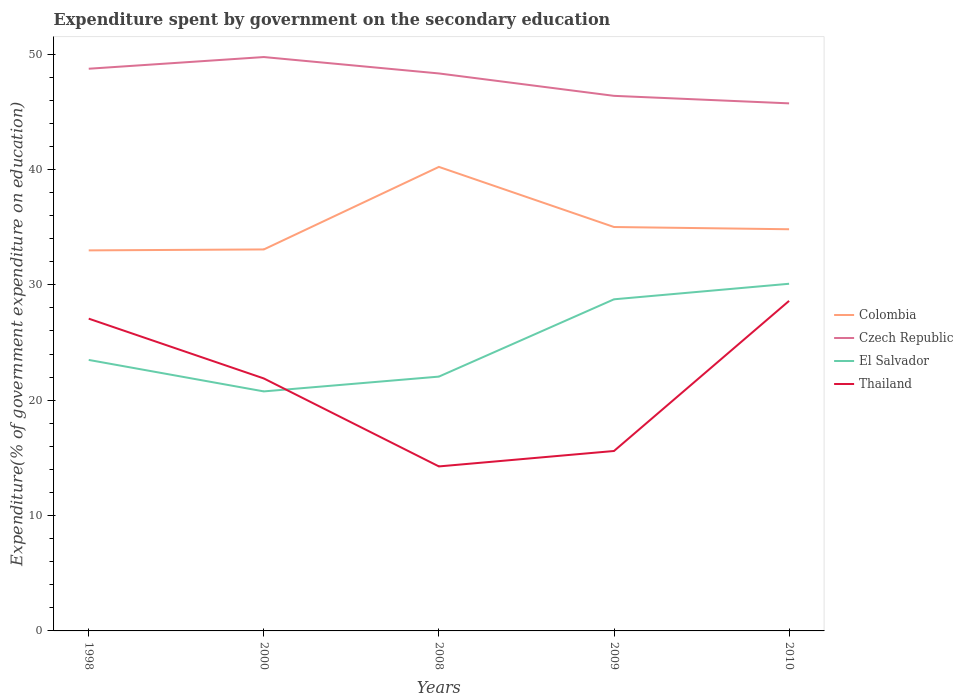How many different coloured lines are there?
Your response must be concise. 4. Does the line corresponding to El Salvador intersect with the line corresponding to Colombia?
Ensure brevity in your answer.  No. Across all years, what is the maximum expenditure spent by government on the secondary education in Thailand?
Keep it short and to the point. 14.26. What is the total expenditure spent by government on the secondary education in El Salvador in the graph?
Your answer should be very brief. -1.35. What is the difference between the highest and the second highest expenditure spent by government on the secondary education in Czech Republic?
Give a very brief answer. 4.02. What is the difference between the highest and the lowest expenditure spent by government on the secondary education in El Salvador?
Your response must be concise. 2. Is the expenditure spent by government on the secondary education in Thailand strictly greater than the expenditure spent by government on the secondary education in El Salvador over the years?
Offer a terse response. No. How many lines are there?
Your answer should be very brief. 4. What is the difference between two consecutive major ticks on the Y-axis?
Keep it short and to the point. 10. Are the values on the major ticks of Y-axis written in scientific E-notation?
Your response must be concise. No. Does the graph contain any zero values?
Offer a very short reply. No. Does the graph contain grids?
Provide a short and direct response. No. Where does the legend appear in the graph?
Your answer should be compact. Center right. How many legend labels are there?
Give a very brief answer. 4. How are the legend labels stacked?
Your response must be concise. Vertical. What is the title of the graph?
Ensure brevity in your answer.  Expenditure spent by government on the secondary education. What is the label or title of the Y-axis?
Your answer should be compact. Expenditure(% of government expenditure on education). What is the Expenditure(% of government expenditure on education) in Colombia in 1998?
Offer a terse response. 32.99. What is the Expenditure(% of government expenditure on education) of Czech Republic in 1998?
Your response must be concise. 48.74. What is the Expenditure(% of government expenditure on education) of El Salvador in 1998?
Provide a short and direct response. 23.49. What is the Expenditure(% of government expenditure on education) in Thailand in 1998?
Provide a succinct answer. 27.07. What is the Expenditure(% of government expenditure on education) of Colombia in 2000?
Offer a terse response. 33.07. What is the Expenditure(% of government expenditure on education) of Czech Republic in 2000?
Provide a short and direct response. 49.75. What is the Expenditure(% of government expenditure on education) of El Salvador in 2000?
Your answer should be very brief. 20.76. What is the Expenditure(% of government expenditure on education) in Thailand in 2000?
Provide a short and direct response. 21.89. What is the Expenditure(% of government expenditure on education) of Colombia in 2008?
Your response must be concise. 40.23. What is the Expenditure(% of government expenditure on education) in Czech Republic in 2008?
Give a very brief answer. 48.33. What is the Expenditure(% of government expenditure on education) in El Salvador in 2008?
Your answer should be compact. 22.05. What is the Expenditure(% of government expenditure on education) of Thailand in 2008?
Keep it short and to the point. 14.26. What is the Expenditure(% of government expenditure on education) in Colombia in 2009?
Provide a short and direct response. 35.01. What is the Expenditure(% of government expenditure on education) of Czech Republic in 2009?
Make the answer very short. 46.39. What is the Expenditure(% of government expenditure on education) in El Salvador in 2009?
Make the answer very short. 28.75. What is the Expenditure(% of government expenditure on education) of Thailand in 2009?
Your answer should be very brief. 15.6. What is the Expenditure(% of government expenditure on education) of Colombia in 2010?
Your answer should be very brief. 34.82. What is the Expenditure(% of government expenditure on education) of Czech Republic in 2010?
Offer a very short reply. 45.73. What is the Expenditure(% of government expenditure on education) in El Salvador in 2010?
Provide a succinct answer. 30.09. What is the Expenditure(% of government expenditure on education) in Thailand in 2010?
Your answer should be very brief. 28.61. Across all years, what is the maximum Expenditure(% of government expenditure on education) in Colombia?
Your answer should be compact. 40.23. Across all years, what is the maximum Expenditure(% of government expenditure on education) in Czech Republic?
Ensure brevity in your answer.  49.75. Across all years, what is the maximum Expenditure(% of government expenditure on education) of El Salvador?
Keep it short and to the point. 30.09. Across all years, what is the maximum Expenditure(% of government expenditure on education) in Thailand?
Your answer should be compact. 28.61. Across all years, what is the minimum Expenditure(% of government expenditure on education) in Colombia?
Your answer should be very brief. 32.99. Across all years, what is the minimum Expenditure(% of government expenditure on education) in Czech Republic?
Your response must be concise. 45.73. Across all years, what is the minimum Expenditure(% of government expenditure on education) of El Salvador?
Keep it short and to the point. 20.76. Across all years, what is the minimum Expenditure(% of government expenditure on education) in Thailand?
Provide a succinct answer. 14.26. What is the total Expenditure(% of government expenditure on education) in Colombia in the graph?
Give a very brief answer. 176.12. What is the total Expenditure(% of government expenditure on education) in Czech Republic in the graph?
Provide a succinct answer. 238.93. What is the total Expenditure(% of government expenditure on education) of El Salvador in the graph?
Give a very brief answer. 125.15. What is the total Expenditure(% of government expenditure on education) of Thailand in the graph?
Keep it short and to the point. 107.43. What is the difference between the Expenditure(% of government expenditure on education) in Colombia in 1998 and that in 2000?
Ensure brevity in your answer.  -0.08. What is the difference between the Expenditure(% of government expenditure on education) of Czech Republic in 1998 and that in 2000?
Make the answer very short. -1.01. What is the difference between the Expenditure(% of government expenditure on education) in El Salvador in 1998 and that in 2000?
Keep it short and to the point. 2.73. What is the difference between the Expenditure(% of government expenditure on education) in Thailand in 1998 and that in 2000?
Your answer should be very brief. 5.18. What is the difference between the Expenditure(% of government expenditure on education) of Colombia in 1998 and that in 2008?
Offer a terse response. -7.24. What is the difference between the Expenditure(% of government expenditure on education) of Czech Republic in 1998 and that in 2008?
Offer a very short reply. 0.41. What is the difference between the Expenditure(% of government expenditure on education) of El Salvador in 1998 and that in 2008?
Keep it short and to the point. 1.45. What is the difference between the Expenditure(% of government expenditure on education) in Thailand in 1998 and that in 2008?
Offer a very short reply. 12.81. What is the difference between the Expenditure(% of government expenditure on education) of Colombia in 1998 and that in 2009?
Give a very brief answer. -2.02. What is the difference between the Expenditure(% of government expenditure on education) in Czech Republic in 1998 and that in 2009?
Offer a very short reply. 2.35. What is the difference between the Expenditure(% of government expenditure on education) in El Salvador in 1998 and that in 2009?
Your response must be concise. -5.25. What is the difference between the Expenditure(% of government expenditure on education) in Thailand in 1998 and that in 2009?
Offer a terse response. 11.47. What is the difference between the Expenditure(% of government expenditure on education) of Colombia in 1998 and that in 2010?
Offer a very short reply. -1.83. What is the difference between the Expenditure(% of government expenditure on education) in Czech Republic in 1998 and that in 2010?
Give a very brief answer. 3. What is the difference between the Expenditure(% of government expenditure on education) in El Salvador in 1998 and that in 2010?
Offer a terse response. -6.6. What is the difference between the Expenditure(% of government expenditure on education) in Thailand in 1998 and that in 2010?
Your answer should be very brief. -1.54. What is the difference between the Expenditure(% of government expenditure on education) of Colombia in 2000 and that in 2008?
Keep it short and to the point. -7.16. What is the difference between the Expenditure(% of government expenditure on education) of Czech Republic in 2000 and that in 2008?
Your answer should be compact. 1.42. What is the difference between the Expenditure(% of government expenditure on education) of El Salvador in 2000 and that in 2008?
Provide a succinct answer. -1.28. What is the difference between the Expenditure(% of government expenditure on education) in Thailand in 2000 and that in 2008?
Provide a succinct answer. 7.63. What is the difference between the Expenditure(% of government expenditure on education) in Colombia in 2000 and that in 2009?
Offer a very short reply. -1.94. What is the difference between the Expenditure(% of government expenditure on education) in Czech Republic in 2000 and that in 2009?
Your response must be concise. 3.36. What is the difference between the Expenditure(% of government expenditure on education) of El Salvador in 2000 and that in 2009?
Your response must be concise. -7.98. What is the difference between the Expenditure(% of government expenditure on education) of Thailand in 2000 and that in 2009?
Your response must be concise. 6.29. What is the difference between the Expenditure(% of government expenditure on education) of Colombia in 2000 and that in 2010?
Your response must be concise. -1.75. What is the difference between the Expenditure(% of government expenditure on education) of Czech Republic in 2000 and that in 2010?
Offer a very short reply. 4.02. What is the difference between the Expenditure(% of government expenditure on education) in El Salvador in 2000 and that in 2010?
Your response must be concise. -9.33. What is the difference between the Expenditure(% of government expenditure on education) of Thailand in 2000 and that in 2010?
Make the answer very short. -6.73. What is the difference between the Expenditure(% of government expenditure on education) of Colombia in 2008 and that in 2009?
Your response must be concise. 5.21. What is the difference between the Expenditure(% of government expenditure on education) in Czech Republic in 2008 and that in 2009?
Your answer should be compact. 1.94. What is the difference between the Expenditure(% of government expenditure on education) of El Salvador in 2008 and that in 2009?
Your answer should be very brief. -6.7. What is the difference between the Expenditure(% of government expenditure on education) of Thailand in 2008 and that in 2009?
Offer a very short reply. -1.34. What is the difference between the Expenditure(% of government expenditure on education) in Colombia in 2008 and that in 2010?
Provide a succinct answer. 5.41. What is the difference between the Expenditure(% of government expenditure on education) in Czech Republic in 2008 and that in 2010?
Give a very brief answer. 2.59. What is the difference between the Expenditure(% of government expenditure on education) of El Salvador in 2008 and that in 2010?
Provide a succinct answer. -8.05. What is the difference between the Expenditure(% of government expenditure on education) in Thailand in 2008 and that in 2010?
Your answer should be compact. -14.35. What is the difference between the Expenditure(% of government expenditure on education) in Colombia in 2009 and that in 2010?
Provide a short and direct response. 0.19. What is the difference between the Expenditure(% of government expenditure on education) in Czech Republic in 2009 and that in 2010?
Your answer should be compact. 0.65. What is the difference between the Expenditure(% of government expenditure on education) in El Salvador in 2009 and that in 2010?
Keep it short and to the point. -1.35. What is the difference between the Expenditure(% of government expenditure on education) in Thailand in 2009 and that in 2010?
Give a very brief answer. -13.01. What is the difference between the Expenditure(% of government expenditure on education) of Colombia in 1998 and the Expenditure(% of government expenditure on education) of Czech Republic in 2000?
Provide a short and direct response. -16.76. What is the difference between the Expenditure(% of government expenditure on education) of Colombia in 1998 and the Expenditure(% of government expenditure on education) of El Salvador in 2000?
Give a very brief answer. 12.23. What is the difference between the Expenditure(% of government expenditure on education) of Colombia in 1998 and the Expenditure(% of government expenditure on education) of Thailand in 2000?
Offer a very short reply. 11.1. What is the difference between the Expenditure(% of government expenditure on education) in Czech Republic in 1998 and the Expenditure(% of government expenditure on education) in El Salvador in 2000?
Offer a very short reply. 27.97. What is the difference between the Expenditure(% of government expenditure on education) in Czech Republic in 1998 and the Expenditure(% of government expenditure on education) in Thailand in 2000?
Your answer should be compact. 26.85. What is the difference between the Expenditure(% of government expenditure on education) of El Salvador in 1998 and the Expenditure(% of government expenditure on education) of Thailand in 2000?
Your answer should be very brief. 1.61. What is the difference between the Expenditure(% of government expenditure on education) in Colombia in 1998 and the Expenditure(% of government expenditure on education) in Czech Republic in 2008?
Your response must be concise. -15.34. What is the difference between the Expenditure(% of government expenditure on education) in Colombia in 1998 and the Expenditure(% of government expenditure on education) in El Salvador in 2008?
Ensure brevity in your answer.  10.94. What is the difference between the Expenditure(% of government expenditure on education) of Colombia in 1998 and the Expenditure(% of government expenditure on education) of Thailand in 2008?
Your answer should be very brief. 18.73. What is the difference between the Expenditure(% of government expenditure on education) of Czech Republic in 1998 and the Expenditure(% of government expenditure on education) of El Salvador in 2008?
Offer a very short reply. 26.69. What is the difference between the Expenditure(% of government expenditure on education) of Czech Republic in 1998 and the Expenditure(% of government expenditure on education) of Thailand in 2008?
Your answer should be compact. 34.47. What is the difference between the Expenditure(% of government expenditure on education) of El Salvador in 1998 and the Expenditure(% of government expenditure on education) of Thailand in 2008?
Offer a very short reply. 9.23. What is the difference between the Expenditure(% of government expenditure on education) of Colombia in 1998 and the Expenditure(% of government expenditure on education) of Czech Republic in 2009?
Make the answer very short. -13.4. What is the difference between the Expenditure(% of government expenditure on education) of Colombia in 1998 and the Expenditure(% of government expenditure on education) of El Salvador in 2009?
Your answer should be very brief. 4.24. What is the difference between the Expenditure(% of government expenditure on education) of Colombia in 1998 and the Expenditure(% of government expenditure on education) of Thailand in 2009?
Keep it short and to the point. 17.39. What is the difference between the Expenditure(% of government expenditure on education) of Czech Republic in 1998 and the Expenditure(% of government expenditure on education) of El Salvador in 2009?
Make the answer very short. 19.99. What is the difference between the Expenditure(% of government expenditure on education) in Czech Republic in 1998 and the Expenditure(% of government expenditure on education) in Thailand in 2009?
Your answer should be very brief. 33.14. What is the difference between the Expenditure(% of government expenditure on education) of El Salvador in 1998 and the Expenditure(% of government expenditure on education) of Thailand in 2009?
Your response must be concise. 7.9. What is the difference between the Expenditure(% of government expenditure on education) in Colombia in 1998 and the Expenditure(% of government expenditure on education) in Czech Republic in 2010?
Give a very brief answer. -12.74. What is the difference between the Expenditure(% of government expenditure on education) of Colombia in 1998 and the Expenditure(% of government expenditure on education) of El Salvador in 2010?
Give a very brief answer. 2.89. What is the difference between the Expenditure(% of government expenditure on education) of Colombia in 1998 and the Expenditure(% of government expenditure on education) of Thailand in 2010?
Provide a short and direct response. 4.38. What is the difference between the Expenditure(% of government expenditure on education) in Czech Republic in 1998 and the Expenditure(% of government expenditure on education) in El Salvador in 2010?
Give a very brief answer. 18.64. What is the difference between the Expenditure(% of government expenditure on education) of Czech Republic in 1998 and the Expenditure(% of government expenditure on education) of Thailand in 2010?
Your answer should be very brief. 20.12. What is the difference between the Expenditure(% of government expenditure on education) of El Salvador in 1998 and the Expenditure(% of government expenditure on education) of Thailand in 2010?
Provide a short and direct response. -5.12. What is the difference between the Expenditure(% of government expenditure on education) of Colombia in 2000 and the Expenditure(% of government expenditure on education) of Czech Republic in 2008?
Ensure brevity in your answer.  -15.26. What is the difference between the Expenditure(% of government expenditure on education) in Colombia in 2000 and the Expenditure(% of government expenditure on education) in El Salvador in 2008?
Provide a succinct answer. 11.02. What is the difference between the Expenditure(% of government expenditure on education) of Colombia in 2000 and the Expenditure(% of government expenditure on education) of Thailand in 2008?
Your response must be concise. 18.81. What is the difference between the Expenditure(% of government expenditure on education) of Czech Republic in 2000 and the Expenditure(% of government expenditure on education) of El Salvador in 2008?
Provide a short and direct response. 27.7. What is the difference between the Expenditure(% of government expenditure on education) of Czech Republic in 2000 and the Expenditure(% of government expenditure on education) of Thailand in 2008?
Offer a very short reply. 35.49. What is the difference between the Expenditure(% of government expenditure on education) of El Salvador in 2000 and the Expenditure(% of government expenditure on education) of Thailand in 2008?
Ensure brevity in your answer.  6.5. What is the difference between the Expenditure(% of government expenditure on education) in Colombia in 2000 and the Expenditure(% of government expenditure on education) in Czech Republic in 2009?
Provide a short and direct response. -13.31. What is the difference between the Expenditure(% of government expenditure on education) in Colombia in 2000 and the Expenditure(% of government expenditure on education) in El Salvador in 2009?
Your response must be concise. 4.32. What is the difference between the Expenditure(% of government expenditure on education) of Colombia in 2000 and the Expenditure(% of government expenditure on education) of Thailand in 2009?
Provide a succinct answer. 17.47. What is the difference between the Expenditure(% of government expenditure on education) of Czech Republic in 2000 and the Expenditure(% of government expenditure on education) of El Salvador in 2009?
Your answer should be very brief. 21. What is the difference between the Expenditure(% of government expenditure on education) of Czech Republic in 2000 and the Expenditure(% of government expenditure on education) of Thailand in 2009?
Your response must be concise. 34.15. What is the difference between the Expenditure(% of government expenditure on education) of El Salvador in 2000 and the Expenditure(% of government expenditure on education) of Thailand in 2009?
Offer a very short reply. 5.17. What is the difference between the Expenditure(% of government expenditure on education) in Colombia in 2000 and the Expenditure(% of government expenditure on education) in Czech Republic in 2010?
Keep it short and to the point. -12.66. What is the difference between the Expenditure(% of government expenditure on education) in Colombia in 2000 and the Expenditure(% of government expenditure on education) in El Salvador in 2010?
Make the answer very short. 2.98. What is the difference between the Expenditure(% of government expenditure on education) in Colombia in 2000 and the Expenditure(% of government expenditure on education) in Thailand in 2010?
Offer a terse response. 4.46. What is the difference between the Expenditure(% of government expenditure on education) of Czech Republic in 2000 and the Expenditure(% of government expenditure on education) of El Salvador in 2010?
Make the answer very short. 19.65. What is the difference between the Expenditure(% of government expenditure on education) of Czech Republic in 2000 and the Expenditure(% of government expenditure on education) of Thailand in 2010?
Provide a short and direct response. 21.14. What is the difference between the Expenditure(% of government expenditure on education) in El Salvador in 2000 and the Expenditure(% of government expenditure on education) in Thailand in 2010?
Provide a short and direct response. -7.85. What is the difference between the Expenditure(% of government expenditure on education) of Colombia in 2008 and the Expenditure(% of government expenditure on education) of Czech Republic in 2009?
Offer a very short reply. -6.16. What is the difference between the Expenditure(% of government expenditure on education) in Colombia in 2008 and the Expenditure(% of government expenditure on education) in El Salvador in 2009?
Offer a terse response. 11.48. What is the difference between the Expenditure(% of government expenditure on education) of Colombia in 2008 and the Expenditure(% of government expenditure on education) of Thailand in 2009?
Keep it short and to the point. 24.63. What is the difference between the Expenditure(% of government expenditure on education) in Czech Republic in 2008 and the Expenditure(% of government expenditure on education) in El Salvador in 2009?
Your answer should be compact. 19.58. What is the difference between the Expenditure(% of government expenditure on education) in Czech Republic in 2008 and the Expenditure(% of government expenditure on education) in Thailand in 2009?
Provide a succinct answer. 32.73. What is the difference between the Expenditure(% of government expenditure on education) of El Salvador in 2008 and the Expenditure(% of government expenditure on education) of Thailand in 2009?
Your answer should be very brief. 6.45. What is the difference between the Expenditure(% of government expenditure on education) of Colombia in 2008 and the Expenditure(% of government expenditure on education) of Czech Republic in 2010?
Your answer should be compact. -5.51. What is the difference between the Expenditure(% of government expenditure on education) in Colombia in 2008 and the Expenditure(% of government expenditure on education) in El Salvador in 2010?
Offer a very short reply. 10.13. What is the difference between the Expenditure(% of government expenditure on education) of Colombia in 2008 and the Expenditure(% of government expenditure on education) of Thailand in 2010?
Provide a succinct answer. 11.61. What is the difference between the Expenditure(% of government expenditure on education) of Czech Republic in 2008 and the Expenditure(% of government expenditure on education) of El Salvador in 2010?
Provide a short and direct response. 18.23. What is the difference between the Expenditure(% of government expenditure on education) in Czech Republic in 2008 and the Expenditure(% of government expenditure on education) in Thailand in 2010?
Your answer should be compact. 19.72. What is the difference between the Expenditure(% of government expenditure on education) in El Salvador in 2008 and the Expenditure(% of government expenditure on education) in Thailand in 2010?
Provide a short and direct response. -6.57. What is the difference between the Expenditure(% of government expenditure on education) in Colombia in 2009 and the Expenditure(% of government expenditure on education) in Czech Republic in 2010?
Make the answer very short. -10.72. What is the difference between the Expenditure(% of government expenditure on education) of Colombia in 2009 and the Expenditure(% of government expenditure on education) of El Salvador in 2010?
Your answer should be compact. 4.92. What is the difference between the Expenditure(% of government expenditure on education) in Colombia in 2009 and the Expenditure(% of government expenditure on education) in Thailand in 2010?
Offer a terse response. 6.4. What is the difference between the Expenditure(% of government expenditure on education) in Czech Republic in 2009 and the Expenditure(% of government expenditure on education) in El Salvador in 2010?
Give a very brief answer. 16.29. What is the difference between the Expenditure(% of government expenditure on education) in Czech Republic in 2009 and the Expenditure(% of government expenditure on education) in Thailand in 2010?
Ensure brevity in your answer.  17.77. What is the difference between the Expenditure(% of government expenditure on education) of El Salvador in 2009 and the Expenditure(% of government expenditure on education) of Thailand in 2010?
Provide a short and direct response. 0.14. What is the average Expenditure(% of government expenditure on education) in Colombia per year?
Your response must be concise. 35.22. What is the average Expenditure(% of government expenditure on education) in Czech Republic per year?
Ensure brevity in your answer.  47.79. What is the average Expenditure(% of government expenditure on education) of El Salvador per year?
Give a very brief answer. 25.03. What is the average Expenditure(% of government expenditure on education) of Thailand per year?
Give a very brief answer. 21.49. In the year 1998, what is the difference between the Expenditure(% of government expenditure on education) of Colombia and Expenditure(% of government expenditure on education) of Czech Republic?
Your response must be concise. -15.75. In the year 1998, what is the difference between the Expenditure(% of government expenditure on education) in Colombia and Expenditure(% of government expenditure on education) in El Salvador?
Ensure brevity in your answer.  9.5. In the year 1998, what is the difference between the Expenditure(% of government expenditure on education) in Colombia and Expenditure(% of government expenditure on education) in Thailand?
Offer a terse response. 5.92. In the year 1998, what is the difference between the Expenditure(% of government expenditure on education) of Czech Republic and Expenditure(% of government expenditure on education) of El Salvador?
Offer a very short reply. 25.24. In the year 1998, what is the difference between the Expenditure(% of government expenditure on education) in Czech Republic and Expenditure(% of government expenditure on education) in Thailand?
Provide a short and direct response. 21.66. In the year 1998, what is the difference between the Expenditure(% of government expenditure on education) in El Salvador and Expenditure(% of government expenditure on education) in Thailand?
Your answer should be compact. -3.58. In the year 2000, what is the difference between the Expenditure(% of government expenditure on education) of Colombia and Expenditure(% of government expenditure on education) of Czech Republic?
Keep it short and to the point. -16.68. In the year 2000, what is the difference between the Expenditure(% of government expenditure on education) of Colombia and Expenditure(% of government expenditure on education) of El Salvador?
Keep it short and to the point. 12.31. In the year 2000, what is the difference between the Expenditure(% of government expenditure on education) of Colombia and Expenditure(% of government expenditure on education) of Thailand?
Offer a terse response. 11.18. In the year 2000, what is the difference between the Expenditure(% of government expenditure on education) of Czech Republic and Expenditure(% of government expenditure on education) of El Salvador?
Your response must be concise. 28.98. In the year 2000, what is the difference between the Expenditure(% of government expenditure on education) of Czech Republic and Expenditure(% of government expenditure on education) of Thailand?
Keep it short and to the point. 27.86. In the year 2000, what is the difference between the Expenditure(% of government expenditure on education) in El Salvador and Expenditure(% of government expenditure on education) in Thailand?
Provide a succinct answer. -1.12. In the year 2008, what is the difference between the Expenditure(% of government expenditure on education) of Colombia and Expenditure(% of government expenditure on education) of Czech Republic?
Provide a short and direct response. -8.1. In the year 2008, what is the difference between the Expenditure(% of government expenditure on education) in Colombia and Expenditure(% of government expenditure on education) in El Salvador?
Keep it short and to the point. 18.18. In the year 2008, what is the difference between the Expenditure(% of government expenditure on education) in Colombia and Expenditure(% of government expenditure on education) in Thailand?
Give a very brief answer. 25.97. In the year 2008, what is the difference between the Expenditure(% of government expenditure on education) in Czech Republic and Expenditure(% of government expenditure on education) in El Salvador?
Provide a succinct answer. 26.28. In the year 2008, what is the difference between the Expenditure(% of government expenditure on education) of Czech Republic and Expenditure(% of government expenditure on education) of Thailand?
Give a very brief answer. 34.07. In the year 2008, what is the difference between the Expenditure(% of government expenditure on education) of El Salvador and Expenditure(% of government expenditure on education) of Thailand?
Your response must be concise. 7.79. In the year 2009, what is the difference between the Expenditure(% of government expenditure on education) in Colombia and Expenditure(% of government expenditure on education) in Czech Republic?
Provide a succinct answer. -11.37. In the year 2009, what is the difference between the Expenditure(% of government expenditure on education) of Colombia and Expenditure(% of government expenditure on education) of El Salvador?
Make the answer very short. 6.27. In the year 2009, what is the difference between the Expenditure(% of government expenditure on education) in Colombia and Expenditure(% of government expenditure on education) in Thailand?
Offer a very short reply. 19.42. In the year 2009, what is the difference between the Expenditure(% of government expenditure on education) in Czech Republic and Expenditure(% of government expenditure on education) in El Salvador?
Provide a succinct answer. 17.64. In the year 2009, what is the difference between the Expenditure(% of government expenditure on education) in Czech Republic and Expenditure(% of government expenditure on education) in Thailand?
Your response must be concise. 30.79. In the year 2009, what is the difference between the Expenditure(% of government expenditure on education) of El Salvador and Expenditure(% of government expenditure on education) of Thailand?
Provide a short and direct response. 13.15. In the year 2010, what is the difference between the Expenditure(% of government expenditure on education) of Colombia and Expenditure(% of government expenditure on education) of Czech Republic?
Ensure brevity in your answer.  -10.91. In the year 2010, what is the difference between the Expenditure(% of government expenditure on education) of Colombia and Expenditure(% of government expenditure on education) of El Salvador?
Offer a very short reply. 4.73. In the year 2010, what is the difference between the Expenditure(% of government expenditure on education) of Colombia and Expenditure(% of government expenditure on education) of Thailand?
Make the answer very short. 6.21. In the year 2010, what is the difference between the Expenditure(% of government expenditure on education) of Czech Republic and Expenditure(% of government expenditure on education) of El Salvador?
Offer a very short reply. 15.64. In the year 2010, what is the difference between the Expenditure(% of government expenditure on education) of Czech Republic and Expenditure(% of government expenditure on education) of Thailand?
Provide a succinct answer. 17.12. In the year 2010, what is the difference between the Expenditure(% of government expenditure on education) in El Salvador and Expenditure(% of government expenditure on education) in Thailand?
Offer a terse response. 1.48. What is the ratio of the Expenditure(% of government expenditure on education) in Czech Republic in 1998 to that in 2000?
Provide a short and direct response. 0.98. What is the ratio of the Expenditure(% of government expenditure on education) in El Salvador in 1998 to that in 2000?
Give a very brief answer. 1.13. What is the ratio of the Expenditure(% of government expenditure on education) in Thailand in 1998 to that in 2000?
Ensure brevity in your answer.  1.24. What is the ratio of the Expenditure(% of government expenditure on education) of Colombia in 1998 to that in 2008?
Make the answer very short. 0.82. What is the ratio of the Expenditure(% of government expenditure on education) in Czech Republic in 1998 to that in 2008?
Offer a terse response. 1.01. What is the ratio of the Expenditure(% of government expenditure on education) in El Salvador in 1998 to that in 2008?
Make the answer very short. 1.07. What is the ratio of the Expenditure(% of government expenditure on education) of Thailand in 1998 to that in 2008?
Offer a terse response. 1.9. What is the ratio of the Expenditure(% of government expenditure on education) of Colombia in 1998 to that in 2009?
Offer a very short reply. 0.94. What is the ratio of the Expenditure(% of government expenditure on education) in Czech Republic in 1998 to that in 2009?
Your answer should be compact. 1.05. What is the ratio of the Expenditure(% of government expenditure on education) of El Salvador in 1998 to that in 2009?
Provide a short and direct response. 0.82. What is the ratio of the Expenditure(% of government expenditure on education) of Thailand in 1998 to that in 2009?
Offer a terse response. 1.74. What is the ratio of the Expenditure(% of government expenditure on education) of Colombia in 1998 to that in 2010?
Make the answer very short. 0.95. What is the ratio of the Expenditure(% of government expenditure on education) of Czech Republic in 1998 to that in 2010?
Your response must be concise. 1.07. What is the ratio of the Expenditure(% of government expenditure on education) in El Salvador in 1998 to that in 2010?
Keep it short and to the point. 0.78. What is the ratio of the Expenditure(% of government expenditure on education) in Thailand in 1998 to that in 2010?
Provide a short and direct response. 0.95. What is the ratio of the Expenditure(% of government expenditure on education) in Colombia in 2000 to that in 2008?
Ensure brevity in your answer.  0.82. What is the ratio of the Expenditure(% of government expenditure on education) of Czech Republic in 2000 to that in 2008?
Keep it short and to the point. 1.03. What is the ratio of the Expenditure(% of government expenditure on education) in El Salvador in 2000 to that in 2008?
Give a very brief answer. 0.94. What is the ratio of the Expenditure(% of government expenditure on education) in Thailand in 2000 to that in 2008?
Make the answer very short. 1.53. What is the ratio of the Expenditure(% of government expenditure on education) in Colombia in 2000 to that in 2009?
Keep it short and to the point. 0.94. What is the ratio of the Expenditure(% of government expenditure on education) of Czech Republic in 2000 to that in 2009?
Offer a very short reply. 1.07. What is the ratio of the Expenditure(% of government expenditure on education) in El Salvador in 2000 to that in 2009?
Offer a very short reply. 0.72. What is the ratio of the Expenditure(% of government expenditure on education) in Thailand in 2000 to that in 2009?
Make the answer very short. 1.4. What is the ratio of the Expenditure(% of government expenditure on education) of Colombia in 2000 to that in 2010?
Provide a short and direct response. 0.95. What is the ratio of the Expenditure(% of government expenditure on education) in Czech Republic in 2000 to that in 2010?
Provide a short and direct response. 1.09. What is the ratio of the Expenditure(% of government expenditure on education) of El Salvador in 2000 to that in 2010?
Offer a terse response. 0.69. What is the ratio of the Expenditure(% of government expenditure on education) in Thailand in 2000 to that in 2010?
Give a very brief answer. 0.76. What is the ratio of the Expenditure(% of government expenditure on education) in Colombia in 2008 to that in 2009?
Give a very brief answer. 1.15. What is the ratio of the Expenditure(% of government expenditure on education) in Czech Republic in 2008 to that in 2009?
Offer a terse response. 1.04. What is the ratio of the Expenditure(% of government expenditure on education) in El Salvador in 2008 to that in 2009?
Offer a terse response. 0.77. What is the ratio of the Expenditure(% of government expenditure on education) of Thailand in 2008 to that in 2009?
Your answer should be very brief. 0.91. What is the ratio of the Expenditure(% of government expenditure on education) of Colombia in 2008 to that in 2010?
Your answer should be very brief. 1.16. What is the ratio of the Expenditure(% of government expenditure on education) in Czech Republic in 2008 to that in 2010?
Your response must be concise. 1.06. What is the ratio of the Expenditure(% of government expenditure on education) of El Salvador in 2008 to that in 2010?
Provide a short and direct response. 0.73. What is the ratio of the Expenditure(% of government expenditure on education) of Thailand in 2008 to that in 2010?
Your answer should be very brief. 0.5. What is the ratio of the Expenditure(% of government expenditure on education) of Colombia in 2009 to that in 2010?
Ensure brevity in your answer.  1.01. What is the ratio of the Expenditure(% of government expenditure on education) in Czech Republic in 2009 to that in 2010?
Provide a short and direct response. 1.01. What is the ratio of the Expenditure(% of government expenditure on education) in El Salvador in 2009 to that in 2010?
Make the answer very short. 0.96. What is the ratio of the Expenditure(% of government expenditure on education) in Thailand in 2009 to that in 2010?
Keep it short and to the point. 0.55. What is the difference between the highest and the second highest Expenditure(% of government expenditure on education) of Colombia?
Give a very brief answer. 5.21. What is the difference between the highest and the second highest Expenditure(% of government expenditure on education) in Czech Republic?
Make the answer very short. 1.01. What is the difference between the highest and the second highest Expenditure(% of government expenditure on education) of El Salvador?
Offer a terse response. 1.35. What is the difference between the highest and the second highest Expenditure(% of government expenditure on education) of Thailand?
Offer a very short reply. 1.54. What is the difference between the highest and the lowest Expenditure(% of government expenditure on education) in Colombia?
Offer a very short reply. 7.24. What is the difference between the highest and the lowest Expenditure(% of government expenditure on education) of Czech Republic?
Your answer should be very brief. 4.02. What is the difference between the highest and the lowest Expenditure(% of government expenditure on education) in El Salvador?
Make the answer very short. 9.33. What is the difference between the highest and the lowest Expenditure(% of government expenditure on education) in Thailand?
Your answer should be very brief. 14.35. 